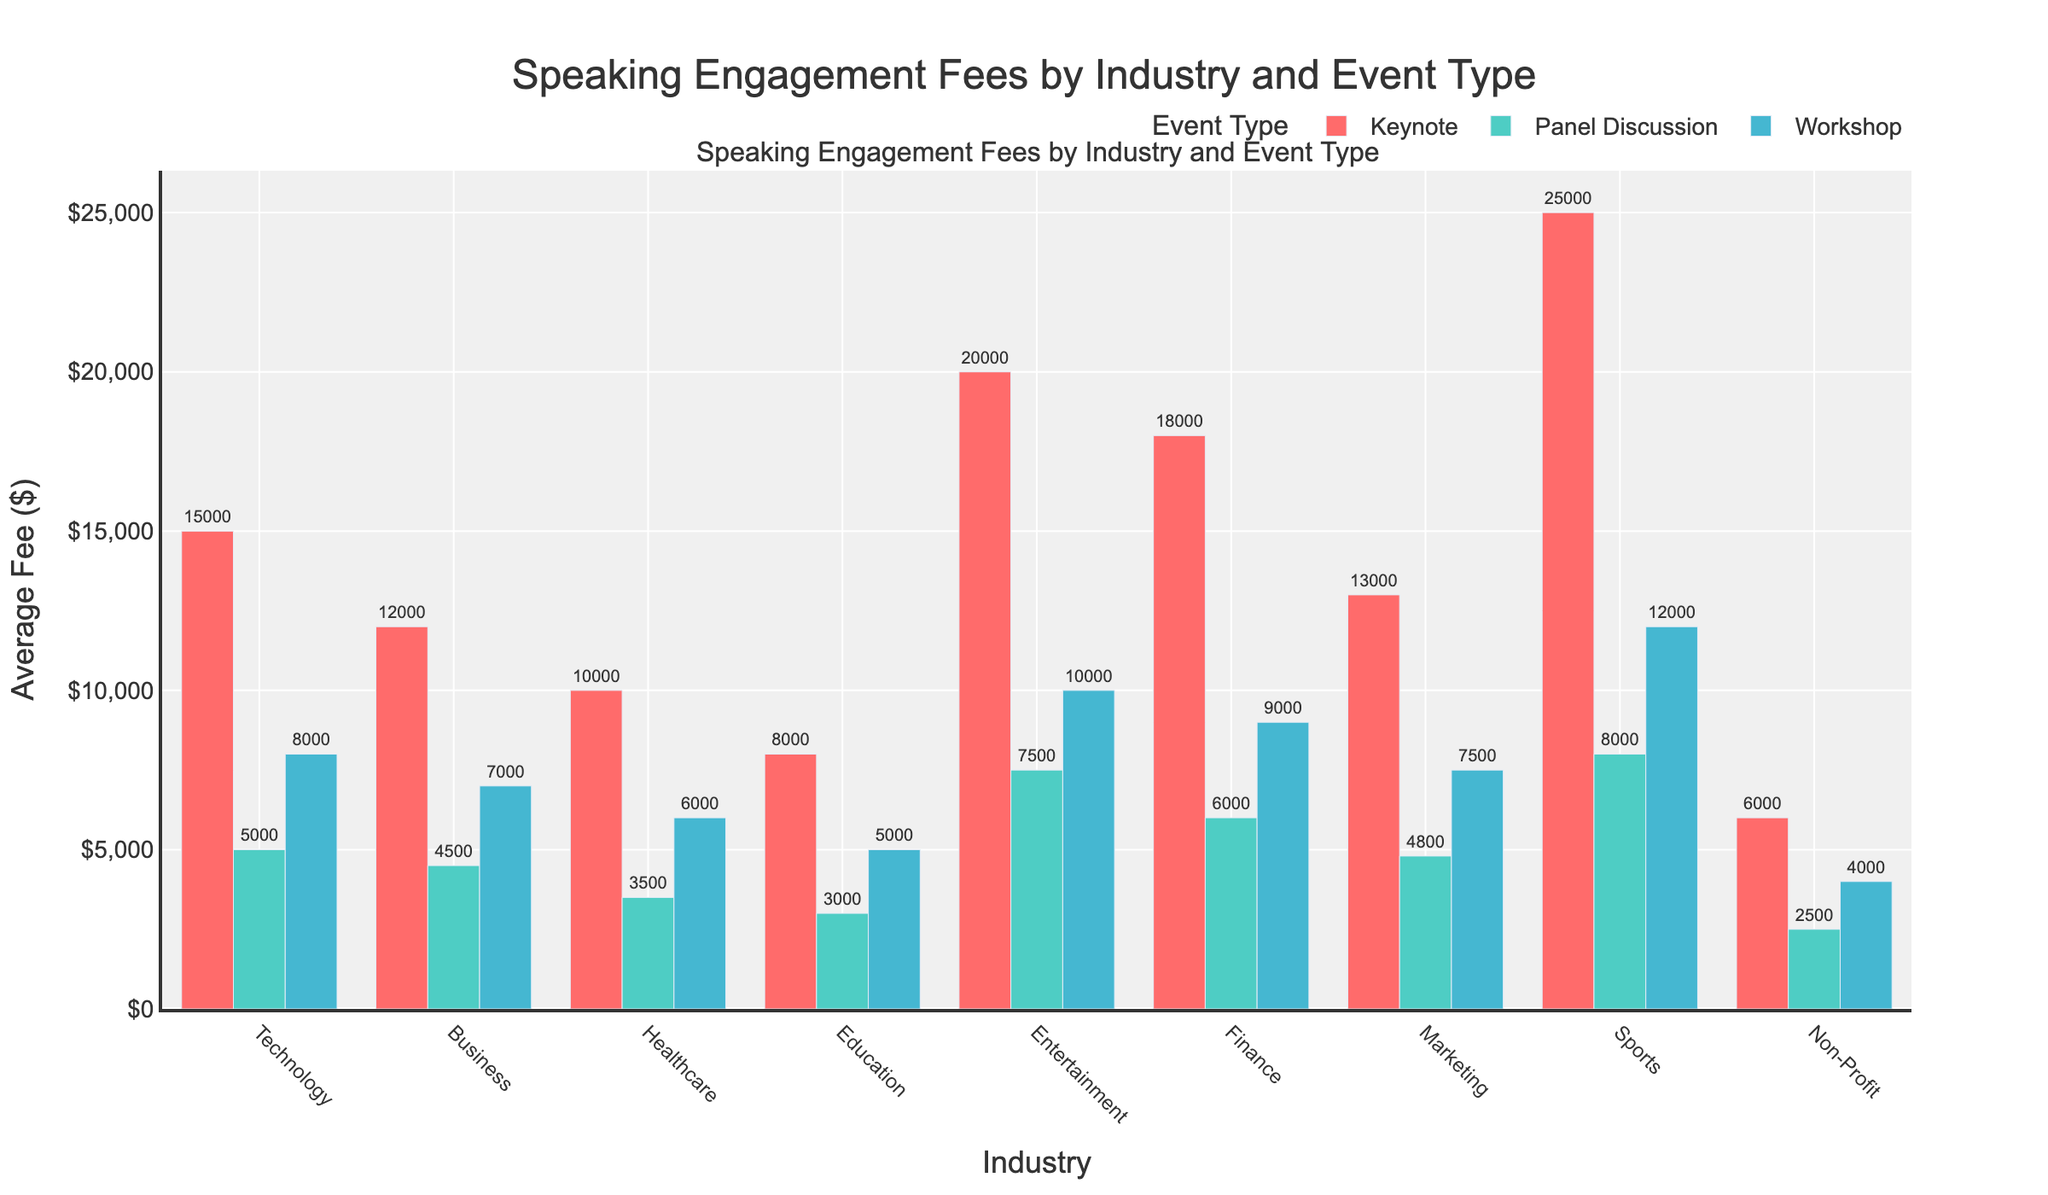What is the industry with the highest average fee for keynote speaking engagements? In the figure, observe the height of the bars for keynote speaking engagements. The highest bar in the "Keynote" category belongs to Sports, which has the highest average fee.
Answer: Sports Which event type in the Technology industry commands the highest average fee? Looking at the Technology section, compare the heights of the bars for Keynote, Panel Discussion, and Workshop. The Keynote bar is the highest.
Answer: Keynote What is the total average fee for keynote engagements across all industries? Sum the heights of the keynote bars for each industry: Technology ($15,000) + Business ($12,000) + Healthcare ($10,000) + Education ($8,000) + Entertainment ($20,000) + Finance ($18,000) + Marketing ($13,000) + Sports ($25,000) + Non-Profit ($6,000), which equals $127,000.
Answer: $127,000 How does the average fee for panel discussions in the Healthcare industry compare to that of the Finance industry? Compare the heights of the panel discussion bars for Healthcare and Finance. Healthcare has $3,500 and Finance has $6,000. Finance is higher.
Answer: Finance has a higher average fee Which event type and in which industry has the lowest average speaking engagement fee? Look for the shortest bar in the entire figure. The shortest bar is for Panel Discussion in the Non-Profit industry with $2,500.
Answer: Panel Discussion in Non-Profit What is the average difference in fees between keynote and workshop events across all industries? For each industry, calculate the difference between keynote and workshop fees, then find the average of these differences:
Technology: 15,000 - 8,000 = 7,000
Business: 12,000 - 7,000 = 5,000
Healthcare: 10,000 - 6,000 = 4,000
Education: 8,000 - 5,000 = 3,000
Entertainment: 20,000 - 10,000 = 10,000
Finance: 18,000 - 9,000 = 9,000
Marketing: 13,000 - 7,500 = 5,500
Sports: 25,000 - 12,000 = 13,000
Non-Profit: 6,000 - 4,000 = 2,000
Average difference = (7,000 + 5,000 + 4,000 + 3,000 + 10,000 + 9,000 + 5,500 + 13,000 + 2,000) / 9 = 6,611
Answer: 6,611 